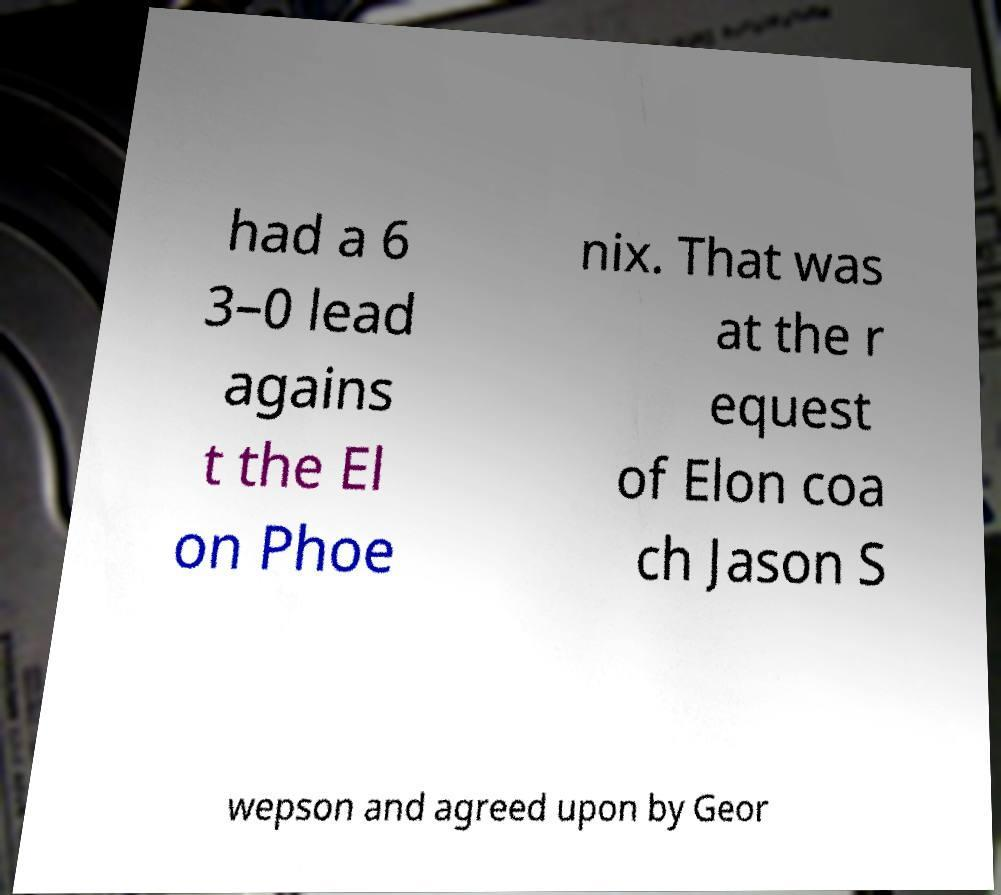Could you extract and type out the text from this image? had a 6 3–0 lead agains t the El on Phoe nix. That was at the r equest of Elon coa ch Jason S wepson and agreed upon by Geor 